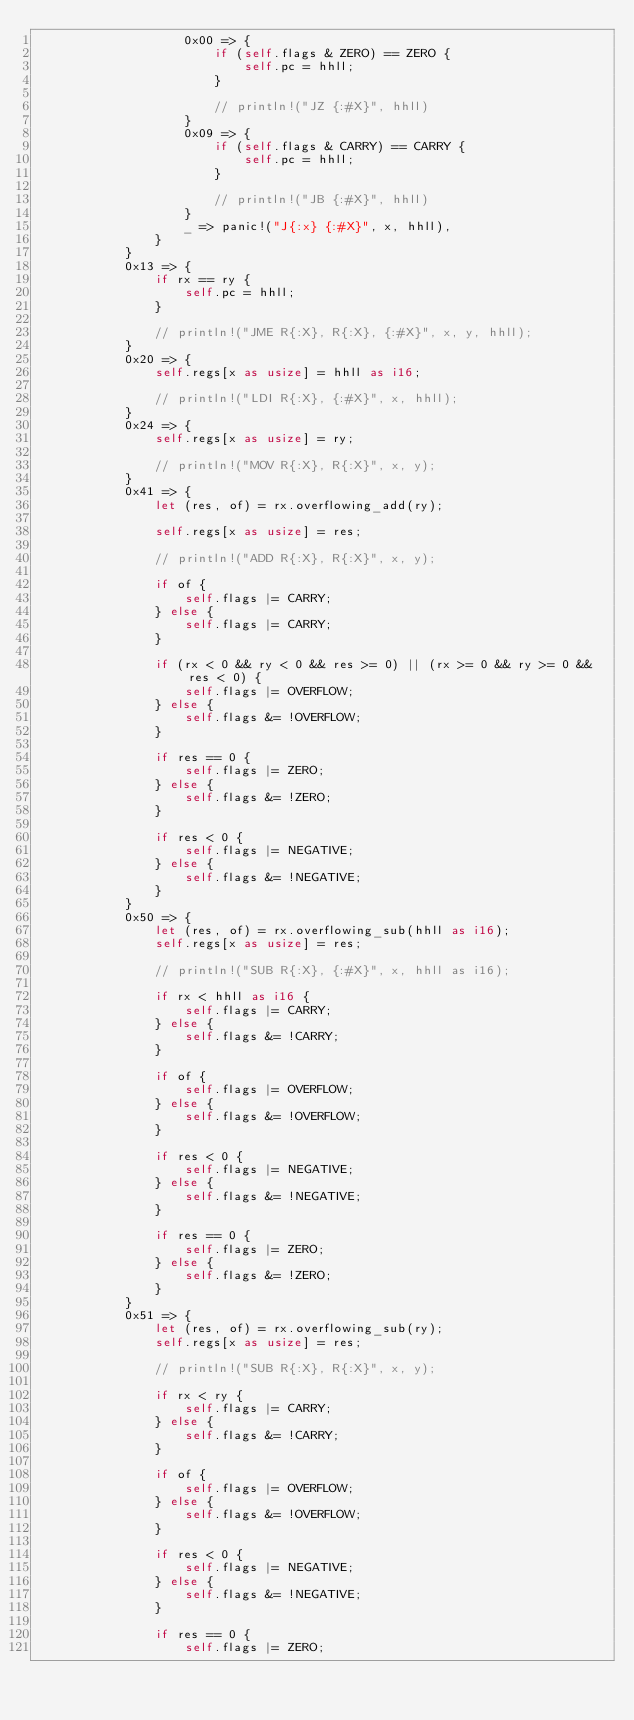Convert code to text. <code><loc_0><loc_0><loc_500><loc_500><_Rust_>                    0x00 => {
                        if (self.flags & ZERO) == ZERO {
                            self.pc = hhll;
                        }

                        // println!("JZ {:#X}", hhll)
                    }
                    0x09 => {
                        if (self.flags & CARRY) == CARRY {
                            self.pc = hhll;
                        }

                        // println!("JB {:#X}", hhll)
                    }
                    _ => panic!("J{:x} {:#X}", x, hhll),
                }
            }
            0x13 => {
                if rx == ry {
                    self.pc = hhll;
                }

                // println!("JME R{:X}, R{:X}, {:#X}", x, y, hhll);
            }
            0x20 => {
                self.regs[x as usize] = hhll as i16;

                // println!("LDI R{:X}, {:#X}", x, hhll);
            }
            0x24 => {
                self.regs[x as usize] = ry;

                // println!("MOV R{:X}, R{:X}", x, y);
            }
            0x41 => {
                let (res, of) = rx.overflowing_add(ry);

                self.regs[x as usize] = res;

                // println!("ADD R{:X}, R{:X}", x, y);

                if of {
                    self.flags |= CARRY;
                } else {
                    self.flags |= CARRY;
                }

                if (rx < 0 && ry < 0 && res >= 0) || (rx >= 0 && ry >= 0 && res < 0) {
                    self.flags |= OVERFLOW;
                } else {
                    self.flags &= !OVERFLOW;
                }

                if res == 0 {
                    self.flags |= ZERO;
                } else {
                    self.flags &= !ZERO;
                }

                if res < 0 {
                    self.flags |= NEGATIVE;
                } else {
                    self.flags &= !NEGATIVE;
                }
            }
            0x50 => {
                let (res, of) = rx.overflowing_sub(hhll as i16);
                self.regs[x as usize] = res;

                // println!("SUB R{:X}, {:#X}", x, hhll as i16);

                if rx < hhll as i16 {
                    self.flags |= CARRY;
                } else {
                    self.flags &= !CARRY;
                }

                if of {
                    self.flags |= OVERFLOW;
                } else {
                    self.flags &= !OVERFLOW;
                }

                if res < 0 {
                    self.flags |= NEGATIVE;
                } else {
                    self.flags &= !NEGATIVE;
                }

                if res == 0 {
                    self.flags |= ZERO;
                } else {
                    self.flags &= !ZERO;
                }
            }
            0x51 => {
                let (res, of) = rx.overflowing_sub(ry);
                self.regs[x as usize] = res;

                // println!("SUB R{:X}, R{:X}", x, y);

                if rx < ry {
                    self.flags |= CARRY;
                } else {
                    self.flags &= !CARRY;
                }

                if of {
                    self.flags |= OVERFLOW;
                } else {
                    self.flags &= !OVERFLOW;
                }

                if res < 0 {
                    self.flags |= NEGATIVE;
                } else {
                    self.flags &= !NEGATIVE;
                }

                if res == 0 {
                    self.flags |= ZERO;</code> 